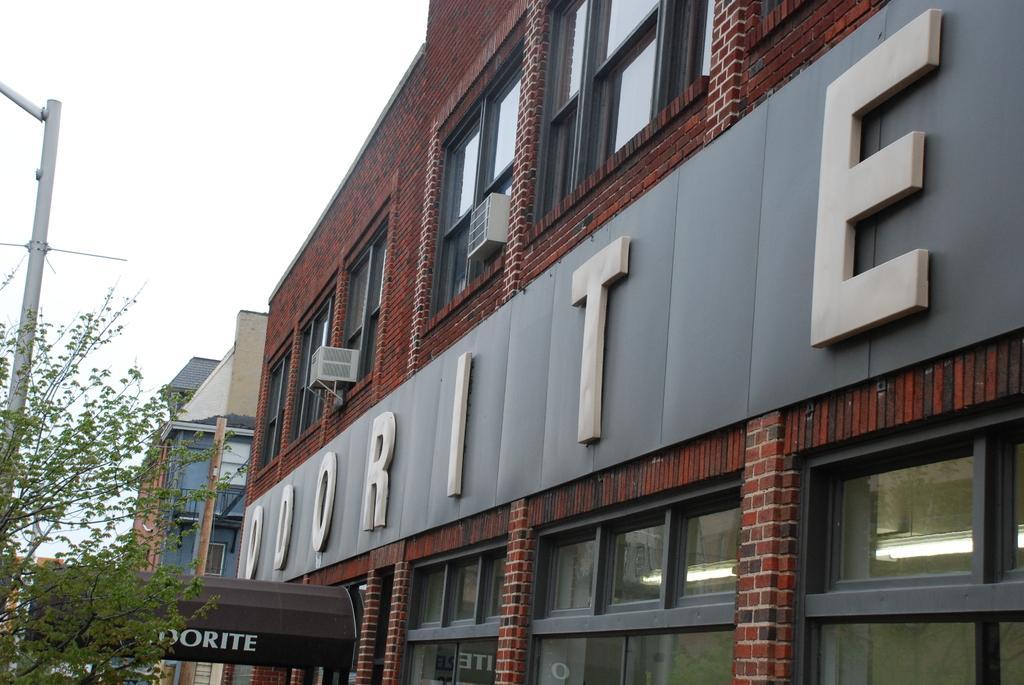Please provide a concise description of this image. In this image I can see a tree, light pole, buildings, board, windows and the sky. This image is taken may be during a day. 